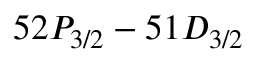<formula> <loc_0><loc_0><loc_500><loc_500>5 2 P _ { 3 / 2 } - 5 1 D _ { 3 / 2 }</formula> 